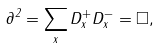<formula> <loc_0><loc_0><loc_500><loc_500>\partial ^ { 2 } = \sum _ { x } D _ { x } ^ { + } D _ { x } ^ { - } = \square ,</formula> 